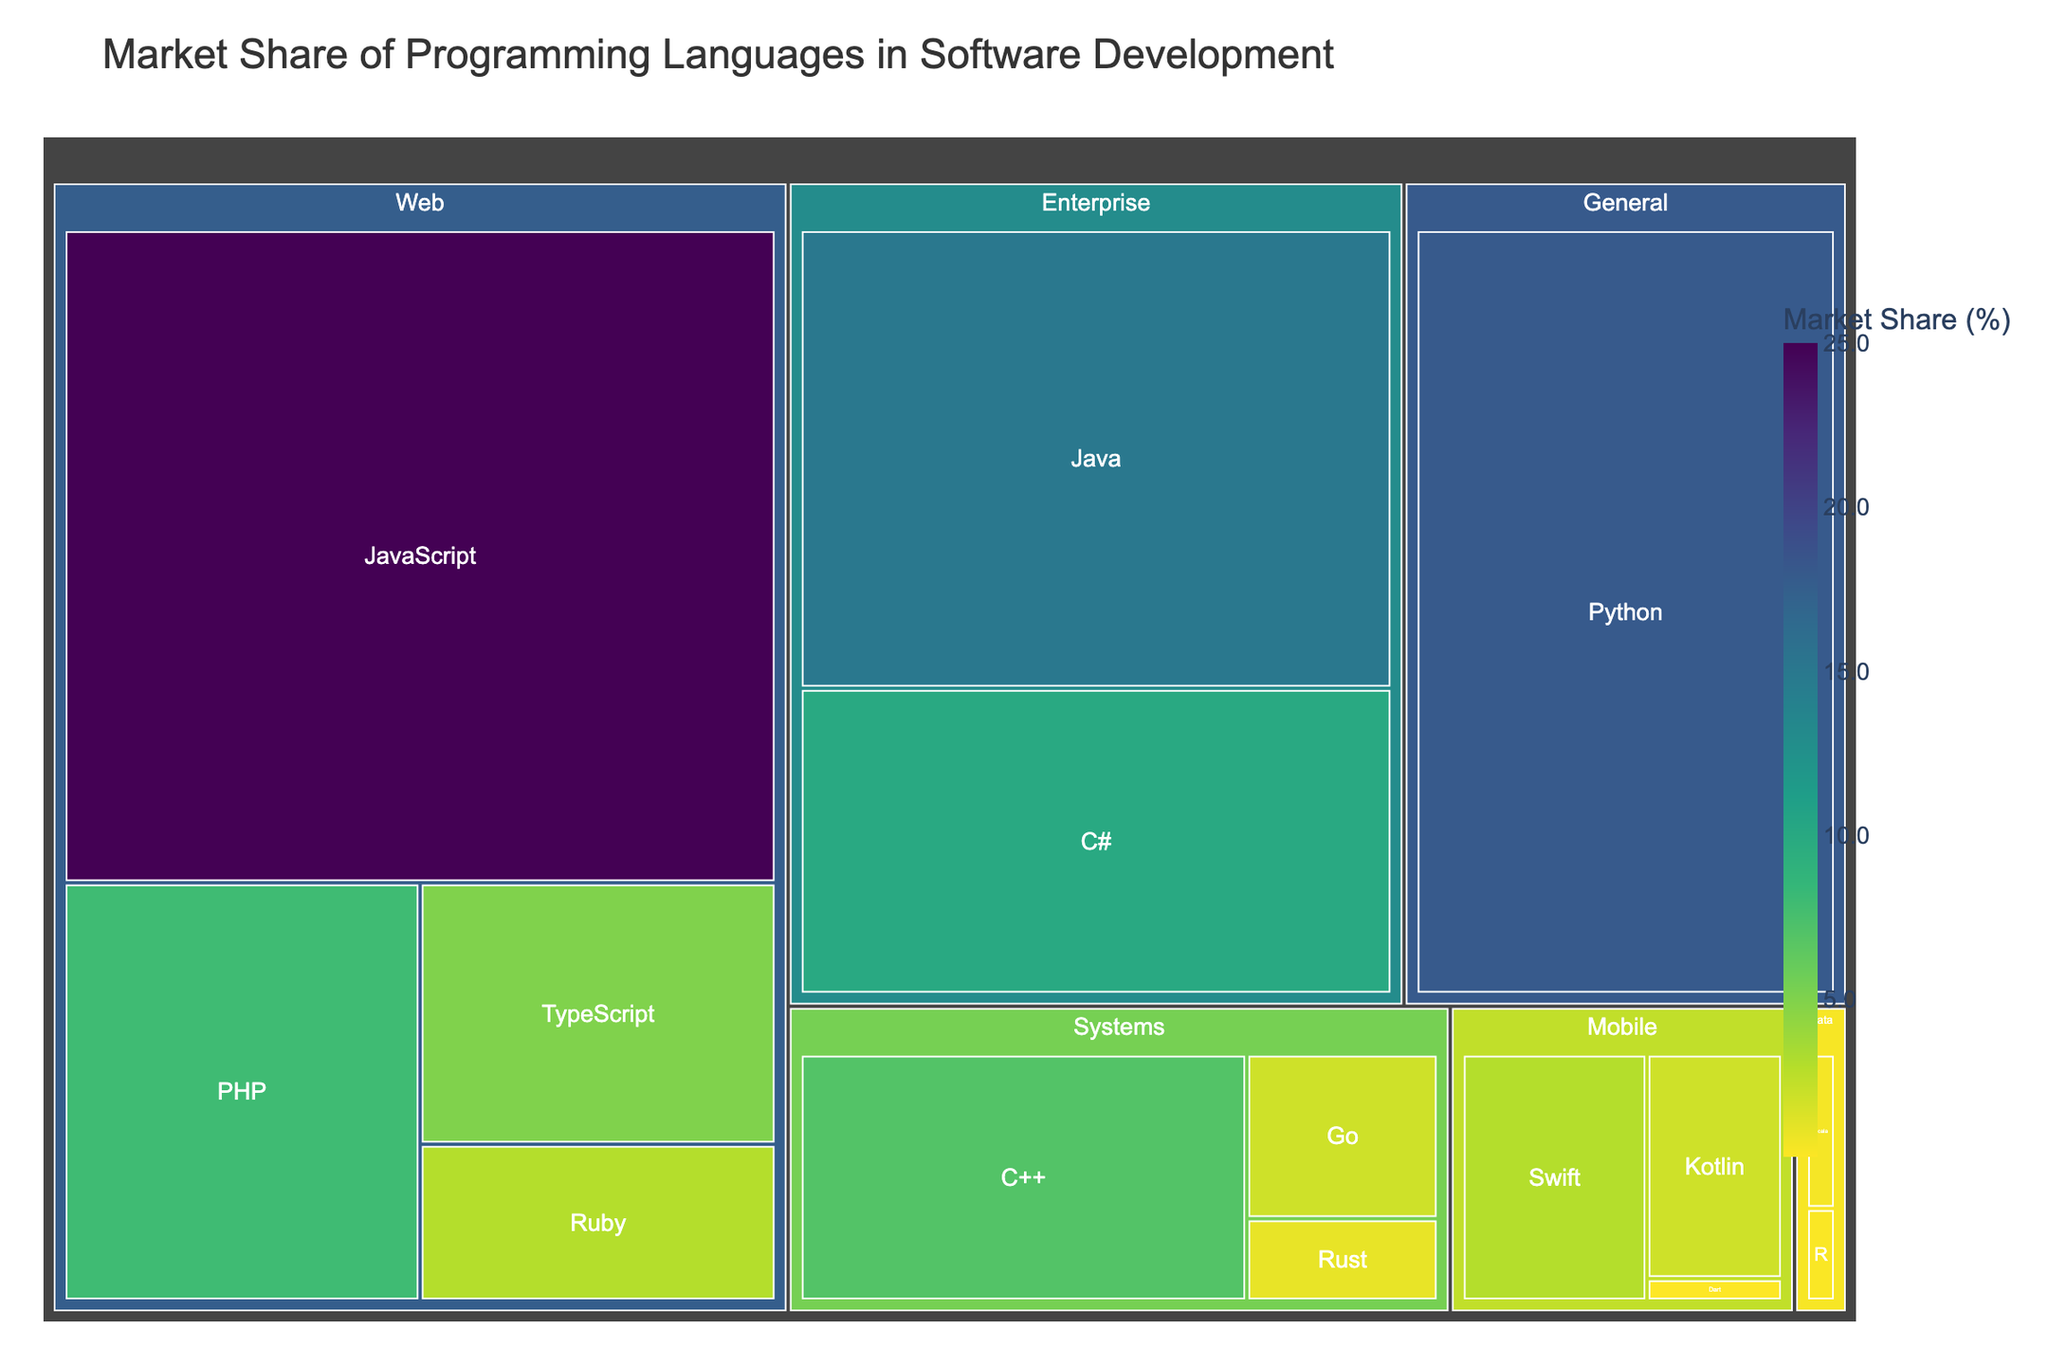How much market share does Python have? The Treemap shows different sections for each programming language with their respective market share. Locate Python's section.
Answer: 18% Which two languages have the smallest market share? Identify the smallest sections in the Treemap, which represent the languages with the least market share.
Answer: Dart and R What is the combined market share of JavaScript and PHP? Find the market share values for JavaScript (25%) and PHP (8%). Add them together: 25% + 8% = 33%.
Answer: 33% Is the market share of Swift greater than that of Kotlin? Look at the sections for Swift and Kotlin. Swift has a market share of 3%, and Kotlin has 2%. Compare 3% with 2%.
Answer: Yes What is the difference in market share between the top two languages? The two languages with the largest market shares are JavaScript (25%) and Python (18%). Subtract Python's market share from JavaScript's: 25% - 18% = 7%.
Answer: 7% How does the market share of mobile languages compare to data languages? Sum the market shares of mobile languages (Swift 3%, Kotlin 2%, Dart 0.2%), and data languages (Scala 0.5%, R 0.3%). Mobile: 3% + 2% + 0.2% = 5.2%. Data: 0.5% + 0.3% = 0.8%. Compare 5.2% with 0.8%.
Answer: Mobile languages have a greater share Which category has the largest total market share, and what is that share? Sum the market shares of languages within each category: Web (JavaScript 25%, PHP 8%, TypeScript 5%, Ruby 3%), General (Python 18%), Enterprise (Java 15%, C# 10%), Systems (C++ 7%, Go 2%, Rust 1%), Mobile (Swift 3%, Kotlin 2%, Dart 0.2%), Data (Scala 0.5%, R 0.3%). Web: 25% + 8% + 5% + 3% = 41%, General: 18%, Enterprise: 15% + 10% = 25%, Systems: 7% + 2% + 1% = 10%, Mobile: 3% + 2% + 0.2% = 5.2%, Data: 0.5% + 0.3% = 0.8%. Web category has the largest share of 41%.
Answer: Web, 41% Which language has the highest market share within the Enterprise category? Check the sections within the Enterprise category. Compare Java (15%) and C# (10%).
Answer: Java How many categories have a combined market share of more than 20%? Sum the market shares for each category: Web 41%, General 18%, Enterprise 25%, Systems 10%, Mobile 5.2%, Data 0.8%. Count how many categories have values greater than 20%.
Answer: Three (Web, General, Enterprise) 